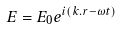<formula> <loc_0><loc_0><loc_500><loc_500>E = E _ { 0 } e ^ { i ( k . r - \omega t ) }</formula> 